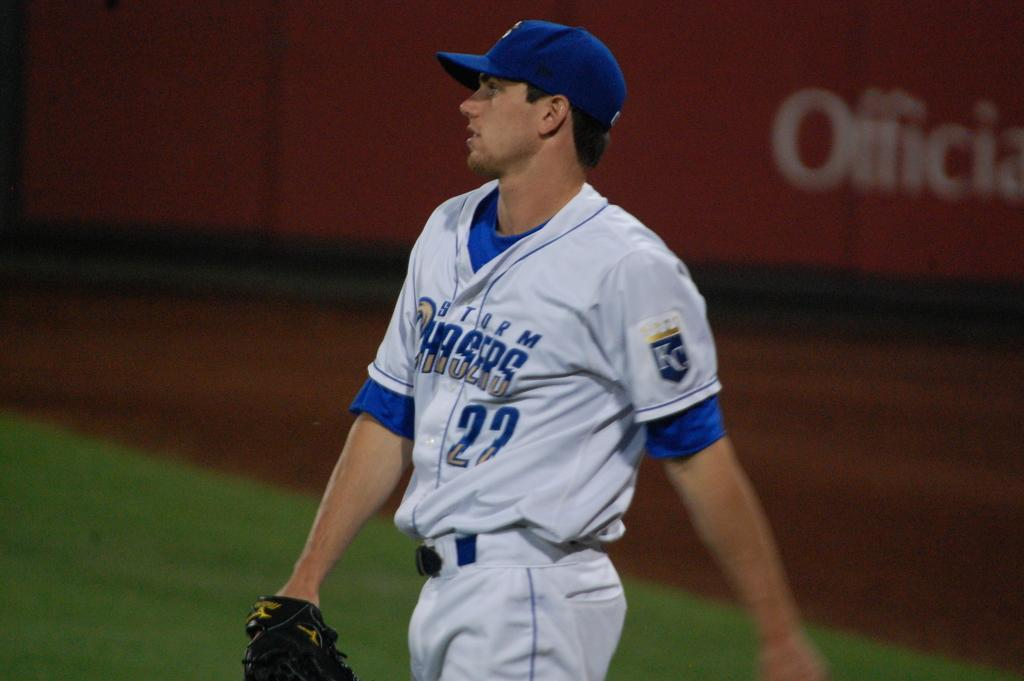<image>
Summarize the visual content of the image. Baseball player number 22 for the team Storm Chasers 